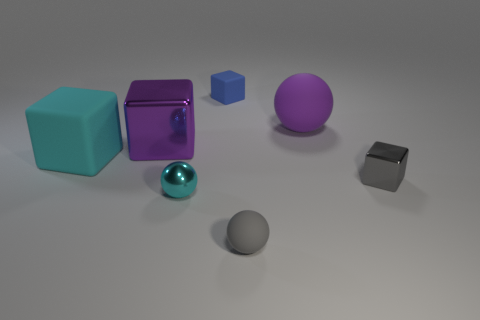Apart from color, how do the textures of the objects compare? The image showcases a variety of textures. The large cubes possess a reflective, glossy finish, while the spheres offer a visual contrast with a matte appearance. The smaller cube and the tiny sphere have a muted, less reflective surface, promoting a subtle comparison in textures. 